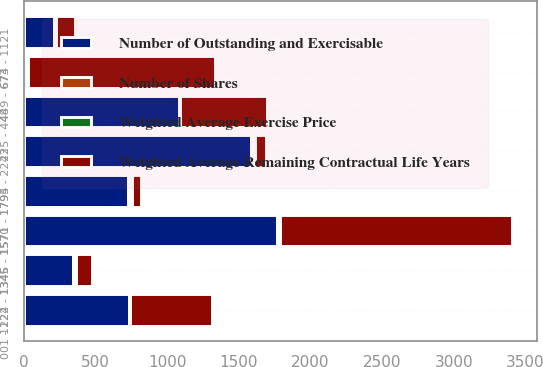Convert chart. <chart><loc_0><loc_0><loc_500><loc_500><stacked_bar_chart><ecel><fcel>001 - 224<fcel>225 - 448<fcel>449 - 673<fcel>674 - 1121<fcel>1122 - 1345<fcel>1346 - 1570<fcel>1571 - 1794<fcel>1795 - 2243<nl><fcel>Number of Outstanding and Exercisable<fcel>732<fcel>1079<fcel>18.95<fcel>208<fcel>342<fcel>1767<fcel>730<fcel>1587<nl><fcel>Number of Shares<fcel>5.8<fcel>6<fcel>7.7<fcel>7.2<fcel>8.9<fcel>3.7<fcel>9.3<fcel>9.2<nl><fcel>Weighted Average Exercise Price<fcel>1.07<fcel>3.45<fcel>5.62<fcel>9.28<fcel>12.39<fcel>14.94<fcel>16.23<fcel>18.95<nl><fcel>Weighted Average Remaining Contractual Life Years<fcel>577<fcel>609<fcel>1302<fcel>129<fcel>111<fcel>1621<fcel>59<fcel>73<nl></chart> 